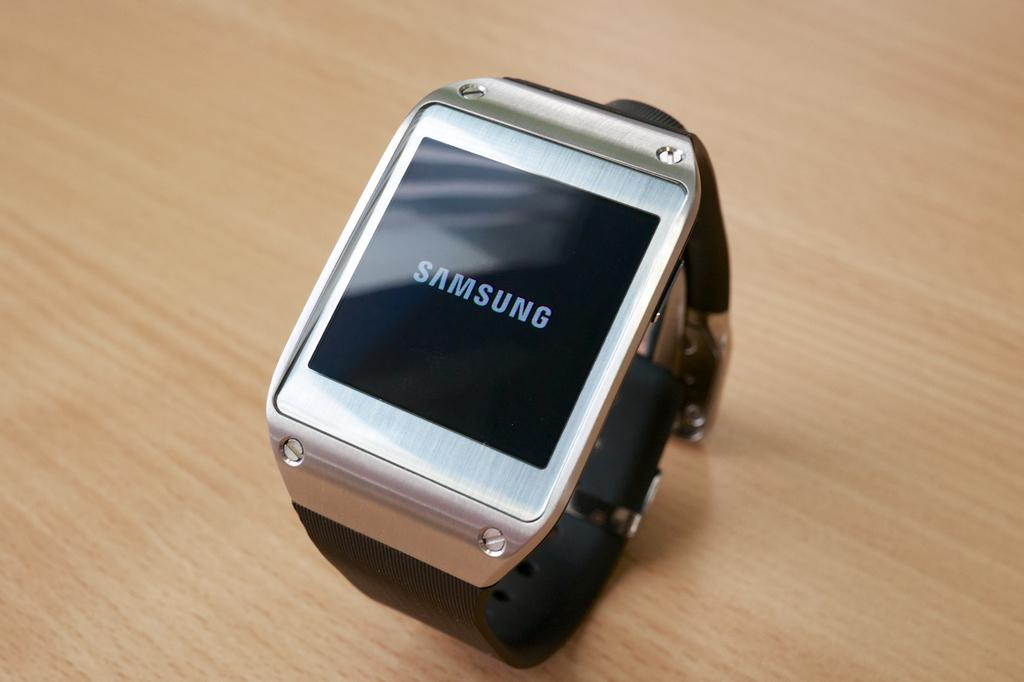<image>
Relay a brief, clear account of the picture shown. A Samsung smart watch sits curled up on a table. 